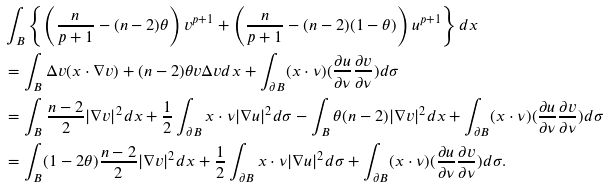<formula> <loc_0><loc_0><loc_500><loc_500>& \int _ { B } \left \{ \left ( \frac { n } { p + 1 } - ( n - 2 ) \theta \right ) v ^ { p + 1 } + \left ( \frac { n } { p + 1 } - ( n - 2 ) ( 1 - \theta ) \right ) u ^ { p + 1 } \right \} d x \\ & = \int _ { B } \Delta v ( x \cdot \nabla v ) + ( n - 2 ) \theta v \Delta v d x + \int _ { \partial B } ( x \cdot \nu ) ( \frac { \partial u } { \partial \nu } \frac { \partial v } { \partial \nu } ) d \sigma \\ & = \int _ { B } \frac { n - 2 } { 2 } | \nabla v | ^ { 2 } d x + \frac { 1 } { 2 } \int _ { \partial B } x \cdot \nu | \nabla u | ^ { 2 } d \sigma - \int _ { B } \theta ( n - 2 ) | \nabla v | ^ { 2 } d x + \int _ { \partial B } ( x \cdot \nu ) ( \frac { \partial u } { \partial \nu } \frac { \partial v } { \partial \nu } ) d \sigma \\ & = \int _ { B } ( 1 - 2 \theta ) \frac { n - 2 } { 2 } | \nabla v | ^ { 2 } d x + \frac { 1 } { 2 } \int _ { \partial B } x \cdot \nu | \nabla u | ^ { 2 } d \sigma + \int _ { \partial B } ( x \cdot \nu ) ( \frac { \partial u } { \partial \nu } \frac { \partial v } { \partial \nu } ) d \sigma .</formula> 